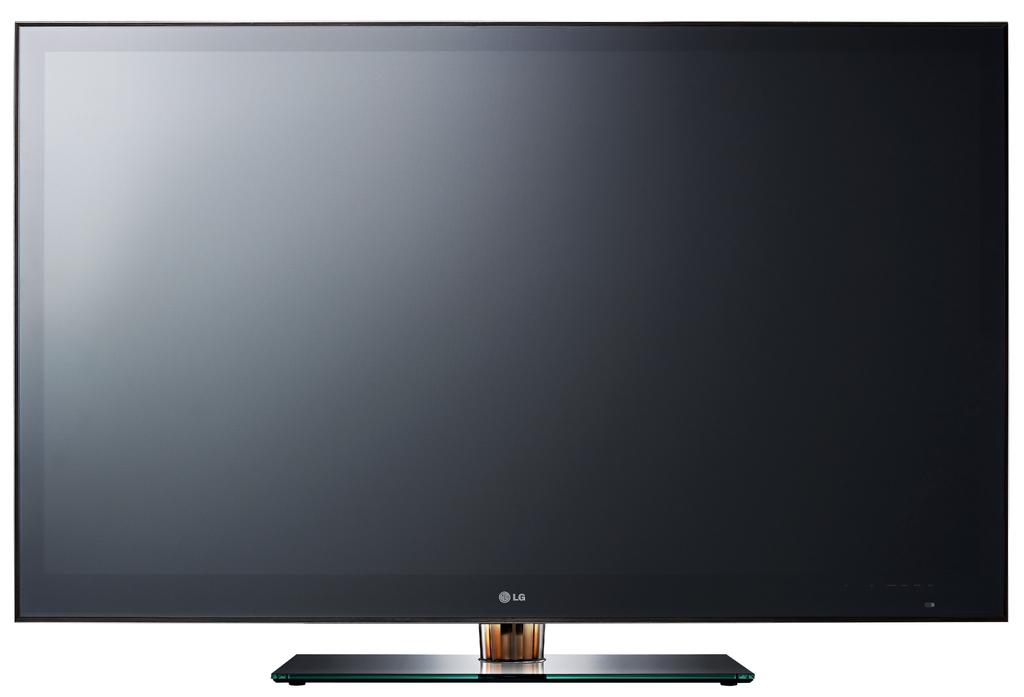<image>
Give a short and clear explanation of the subsequent image. An LG TV or computer monitor that has a one legged stand on it. 